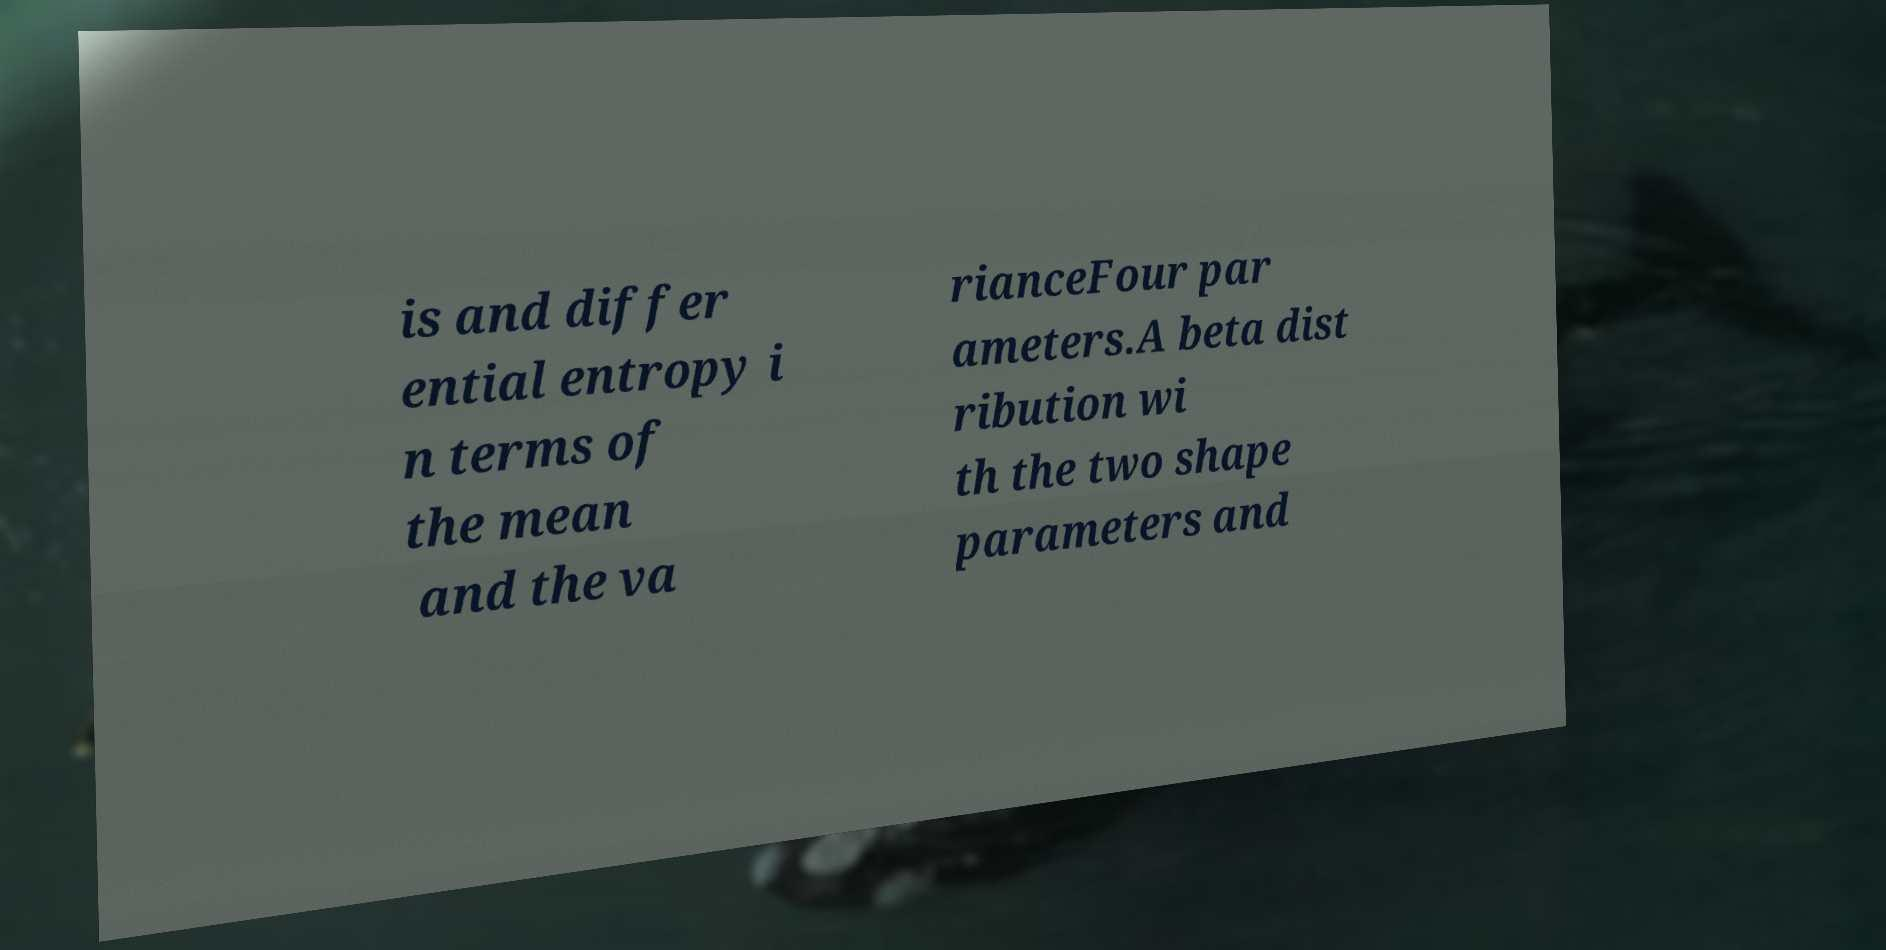I need the written content from this picture converted into text. Can you do that? is and differ ential entropy i n terms of the mean and the va rianceFour par ameters.A beta dist ribution wi th the two shape parameters and 